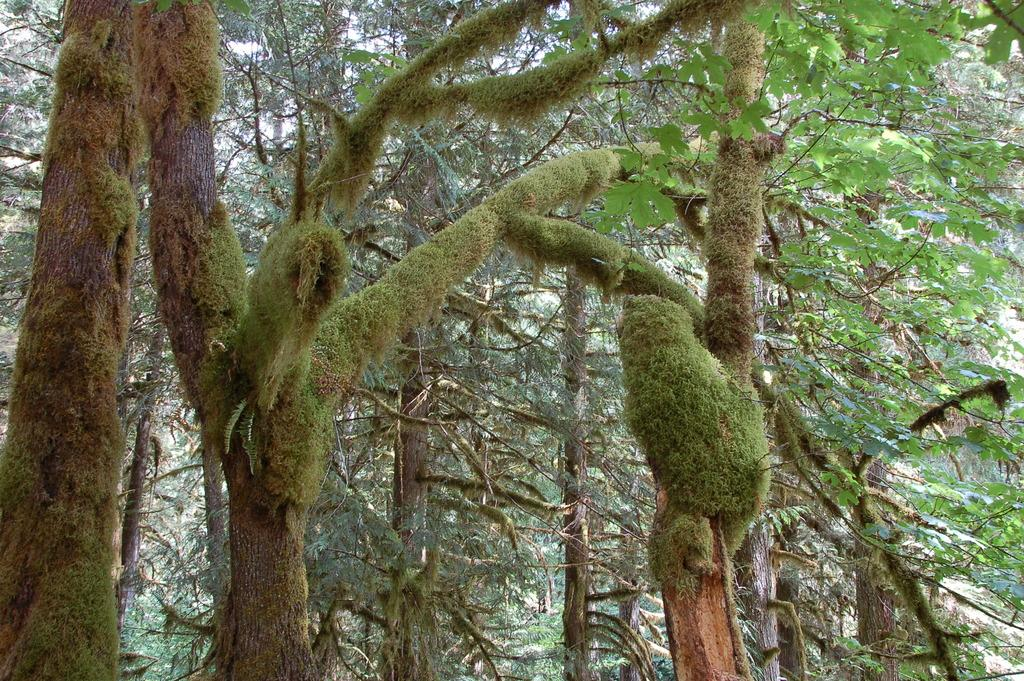What is the main feature of the image? There are many trees in the image. What can be seen on the right side of the image? There are green leaves visible on the right side of the image. What is visible in the background of the image? There is a mountain in the background of the image. What type of pen is being used to write on the mountain in the image? There is no pen or writing visible on the mountain in the image. 